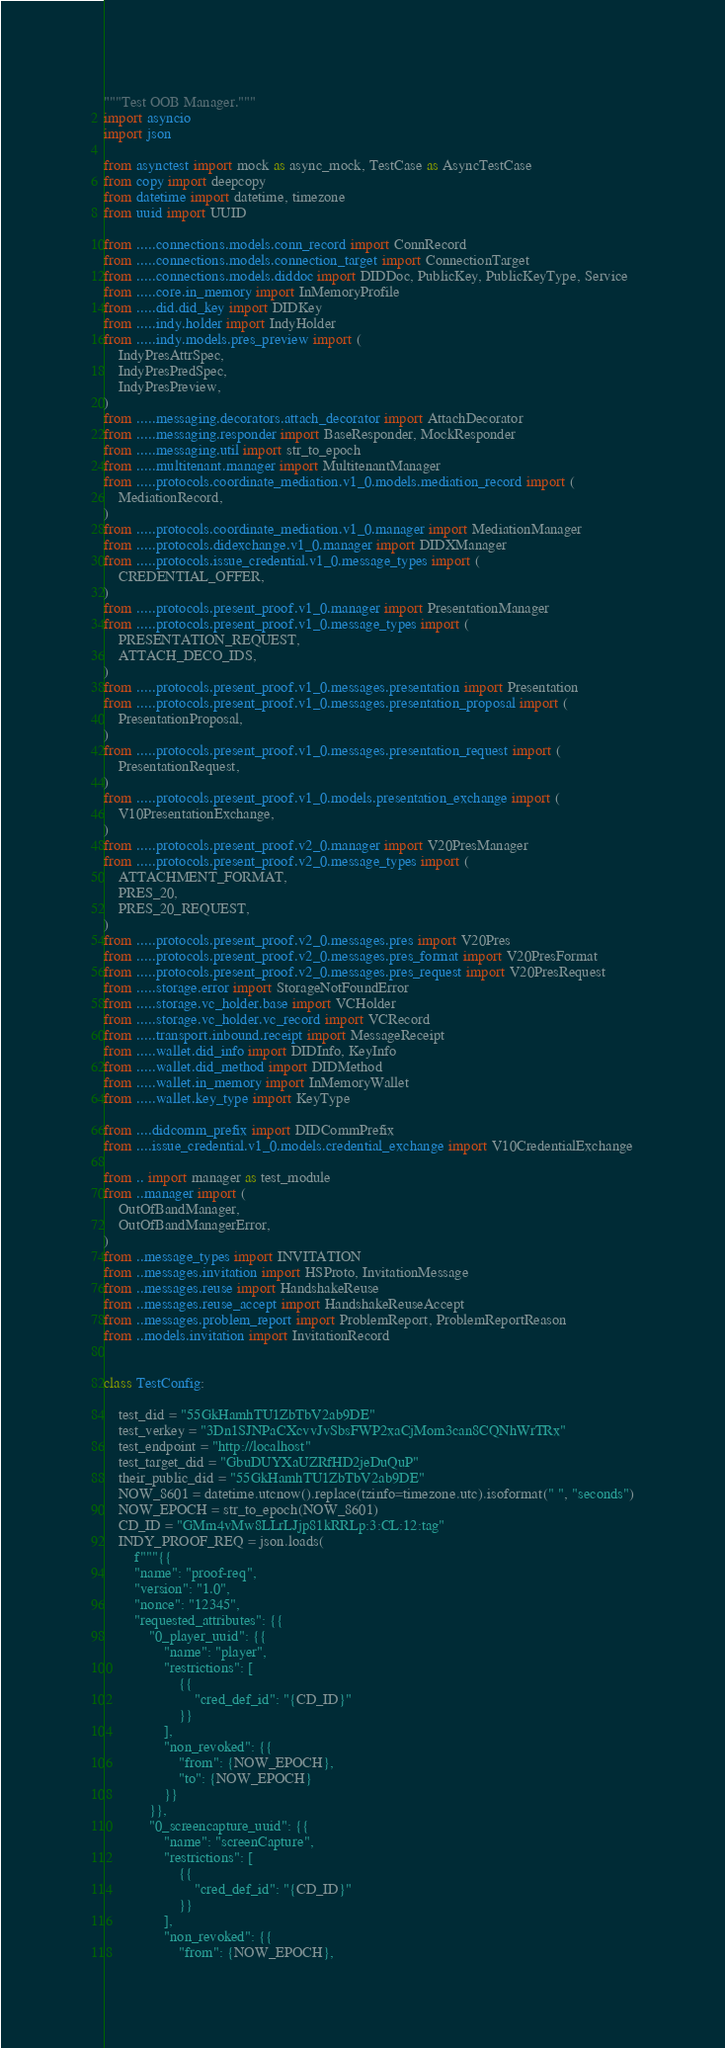Convert code to text. <code><loc_0><loc_0><loc_500><loc_500><_Python_>"""Test OOB Manager."""
import asyncio
import json

from asynctest import mock as async_mock, TestCase as AsyncTestCase
from copy import deepcopy
from datetime import datetime, timezone
from uuid import UUID

from .....connections.models.conn_record import ConnRecord
from .....connections.models.connection_target import ConnectionTarget
from .....connections.models.diddoc import DIDDoc, PublicKey, PublicKeyType, Service
from .....core.in_memory import InMemoryProfile
from .....did.did_key import DIDKey
from .....indy.holder import IndyHolder
from .....indy.models.pres_preview import (
    IndyPresAttrSpec,
    IndyPresPredSpec,
    IndyPresPreview,
)
from .....messaging.decorators.attach_decorator import AttachDecorator
from .....messaging.responder import BaseResponder, MockResponder
from .....messaging.util import str_to_epoch
from .....multitenant.manager import MultitenantManager
from .....protocols.coordinate_mediation.v1_0.models.mediation_record import (
    MediationRecord,
)
from .....protocols.coordinate_mediation.v1_0.manager import MediationManager
from .....protocols.didexchange.v1_0.manager import DIDXManager
from .....protocols.issue_credential.v1_0.message_types import (
    CREDENTIAL_OFFER,
)
from .....protocols.present_proof.v1_0.manager import PresentationManager
from .....protocols.present_proof.v1_0.message_types import (
    PRESENTATION_REQUEST,
    ATTACH_DECO_IDS,
)
from .....protocols.present_proof.v1_0.messages.presentation import Presentation
from .....protocols.present_proof.v1_0.messages.presentation_proposal import (
    PresentationProposal,
)
from .....protocols.present_proof.v1_0.messages.presentation_request import (
    PresentationRequest,
)
from .....protocols.present_proof.v1_0.models.presentation_exchange import (
    V10PresentationExchange,
)
from .....protocols.present_proof.v2_0.manager import V20PresManager
from .....protocols.present_proof.v2_0.message_types import (
    ATTACHMENT_FORMAT,
    PRES_20,
    PRES_20_REQUEST,
)
from .....protocols.present_proof.v2_0.messages.pres import V20Pres
from .....protocols.present_proof.v2_0.messages.pres_format import V20PresFormat
from .....protocols.present_proof.v2_0.messages.pres_request import V20PresRequest
from .....storage.error import StorageNotFoundError
from .....storage.vc_holder.base import VCHolder
from .....storage.vc_holder.vc_record import VCRecord
from .....transport.inbound.receipt import MessageReceipt
from .....wallet.did_info import DIDInfo, KeyInfo
from .....wallet.did_method import DIDMethod
from .....wallet.in_memory import InMemoryWallet
from .....wallet.key_type import KeyType

from ....didcomm_prefix import DIDCommPrefix
from ....issue_credential.v1_0.models.credential_exchange import V10CredentialExchange

from .. import manager as test_module
from ..manager import (
    OutOfBandManager,
    OutOfBandManagerError,
)
from ..message_types import INVITATION
from ..messages.invitation import HSProto, InvitationMessage
from ..messages.reuse import HandshakeReuse
from ..messages.reuse_accept import HandshakeReuseAccept
from ..messages.problem_report import ProblemReport, ProblemReportReason
from ..models.invitation import InvitationRecord


class TestConfig:

    test_did = "55GkHamhTU1ZbTbV2ab9DE"
    test_verkey = "3Dn1SJNPaCXcvvJvSbsFWP2xaCjMom3can8CQNhWrTRx"
    test_endpoint = "http://localhost"
    test_target_did = "GbuDUYXaUZRfHD2jeDuQuP"
    their_public_did = "55GkHamhTU1ZbTbV2ab9DE"
    NOW_8601 = datetime.utcnow().replace(tzinfo=timezone.utc).isoformat(" ", "seconds")
    NOW_EPOCH = str_to_epoch(NOW_8601)
    CD_ID = "GMm4vMw8LLrLJjp81kRRLp:3:CL:12:tag"
    INDY_PROOF_REQ = json.loads(
        f"""{{
        "name": "proof-req",
        "version": "1.0",
        "nonce": "12345",
        "requested_attributes": {{
            "0_player_uuid": {{
                "name": "player",
                "restrictions": [
                    {{
                        "cred_def_id": "{CD_ID}"
                    }}
                ],
                "non_revoked": {{
                    "from": {NOW_EPOCH},
                    "to": {NOW_EPOCH}
                }}
            }},
            "0_screencapture_uuid": {{
                "name": "screenCapture",
                "restrictions": [
                    {{
                        "cred_def_id": "{CD_ID}"
                    }}
                ],
                "non_revoked": {{
                    "from": {NOW_EPOCH},</code> 